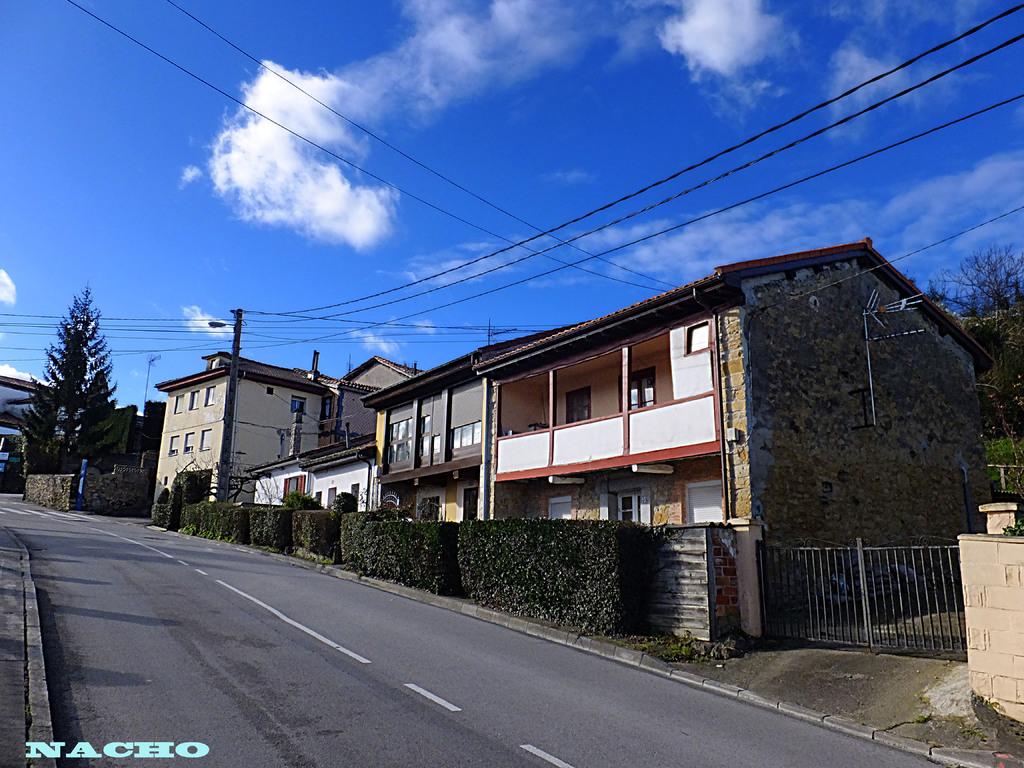Is a number seen on the houses?
Make the answer very short. Yes. Whats written in the bottom left corner?
Give a very brief answer. Nacho. 